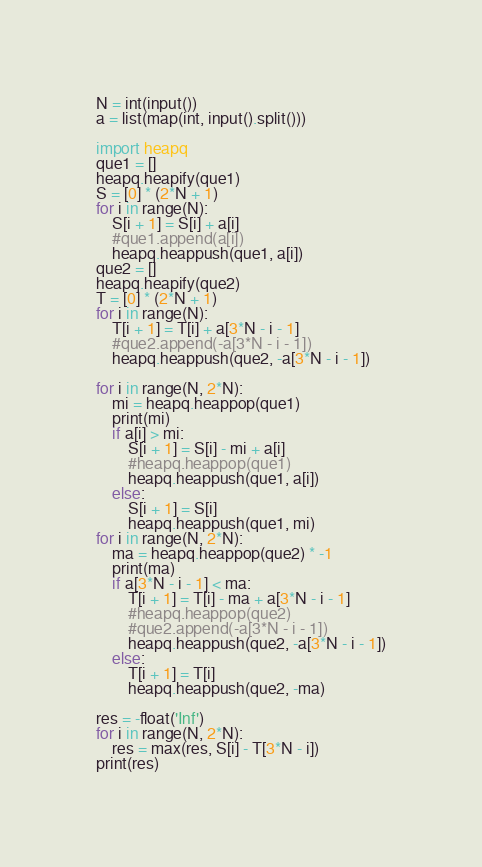<code> <loc_0><loc_0><loc_500><loc_500><_Python_>N = int(input())
a = list(map(int, input().split()))

import heapq
que1 = []
heapq.heapify(que1)
S = [0] * (2*N + 1)
for i in range(N):
    S[i + 1] = S[i] + a[i]
    #que1.append(a[i])
    heapq.heappush(que1, a[i])
que2 = []
heapq.heapify(que2)
T = [0] * (2*N + 1)
for i in range(N):
    T[i + 1] = T[i] + a[3*N - i - 1]
    #que2.append(-a[3*N - i - 1])
    heapq.heappush(que2, -a[3*N - i - 1])

for i in range(N, 2*N):
    mi = heapq.heappop(que1)
    print(mi)
    if a[i] > mi:
        S[i + 1] = S[i] - mi + a[i]
        #heapq.heappop(que1)
        heapq.heappush(que1, a[i])
    else:
        S[i + 1] = S[i]
        heapq.heappush(que1, mi)
for i in range(N, 2*N):
    ma = heapq.heappop(que2) * -1
    print(ma)
    if a[3*N - i - 1] < ma:
        T[i + 1] = T[i] - ma + a[3*N - i - 1]
        #heapq.heappop(que2)
        #que2.append(-a[3*N - i - 1])
        heapq.heappush(que2, -a[3*N - i - 1])
    else:
        T[i + 1] = T[i]
        heapq.heappush(que2, -ma)

res = -float('Inf')
for i in range(N, 2*N):
    res = max(res, S[i] - T[3*N - i])
print(res)</code> 